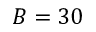<formula> <loc_0><loc_0><loc_500><loc_500>B = 3 0</formula> 